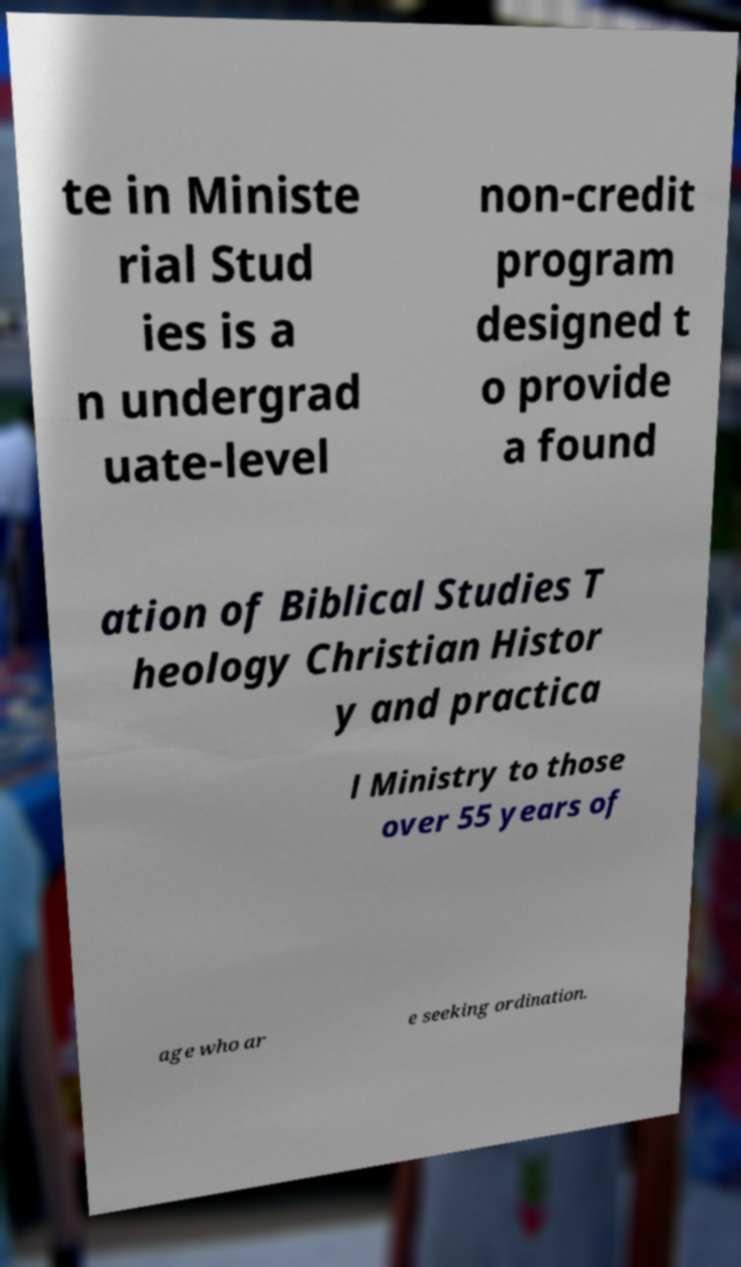For documentation purposes, I need the text within this image transcribed. Could you provide that? te in Ministe rial Stud ies is a n undergrad uate-level non-credit program designed t o provide a found ation of Biblical Studies T heology Christian Histor y and practica l Ministry to those over 55 years of age who ar e seeking ordination. 